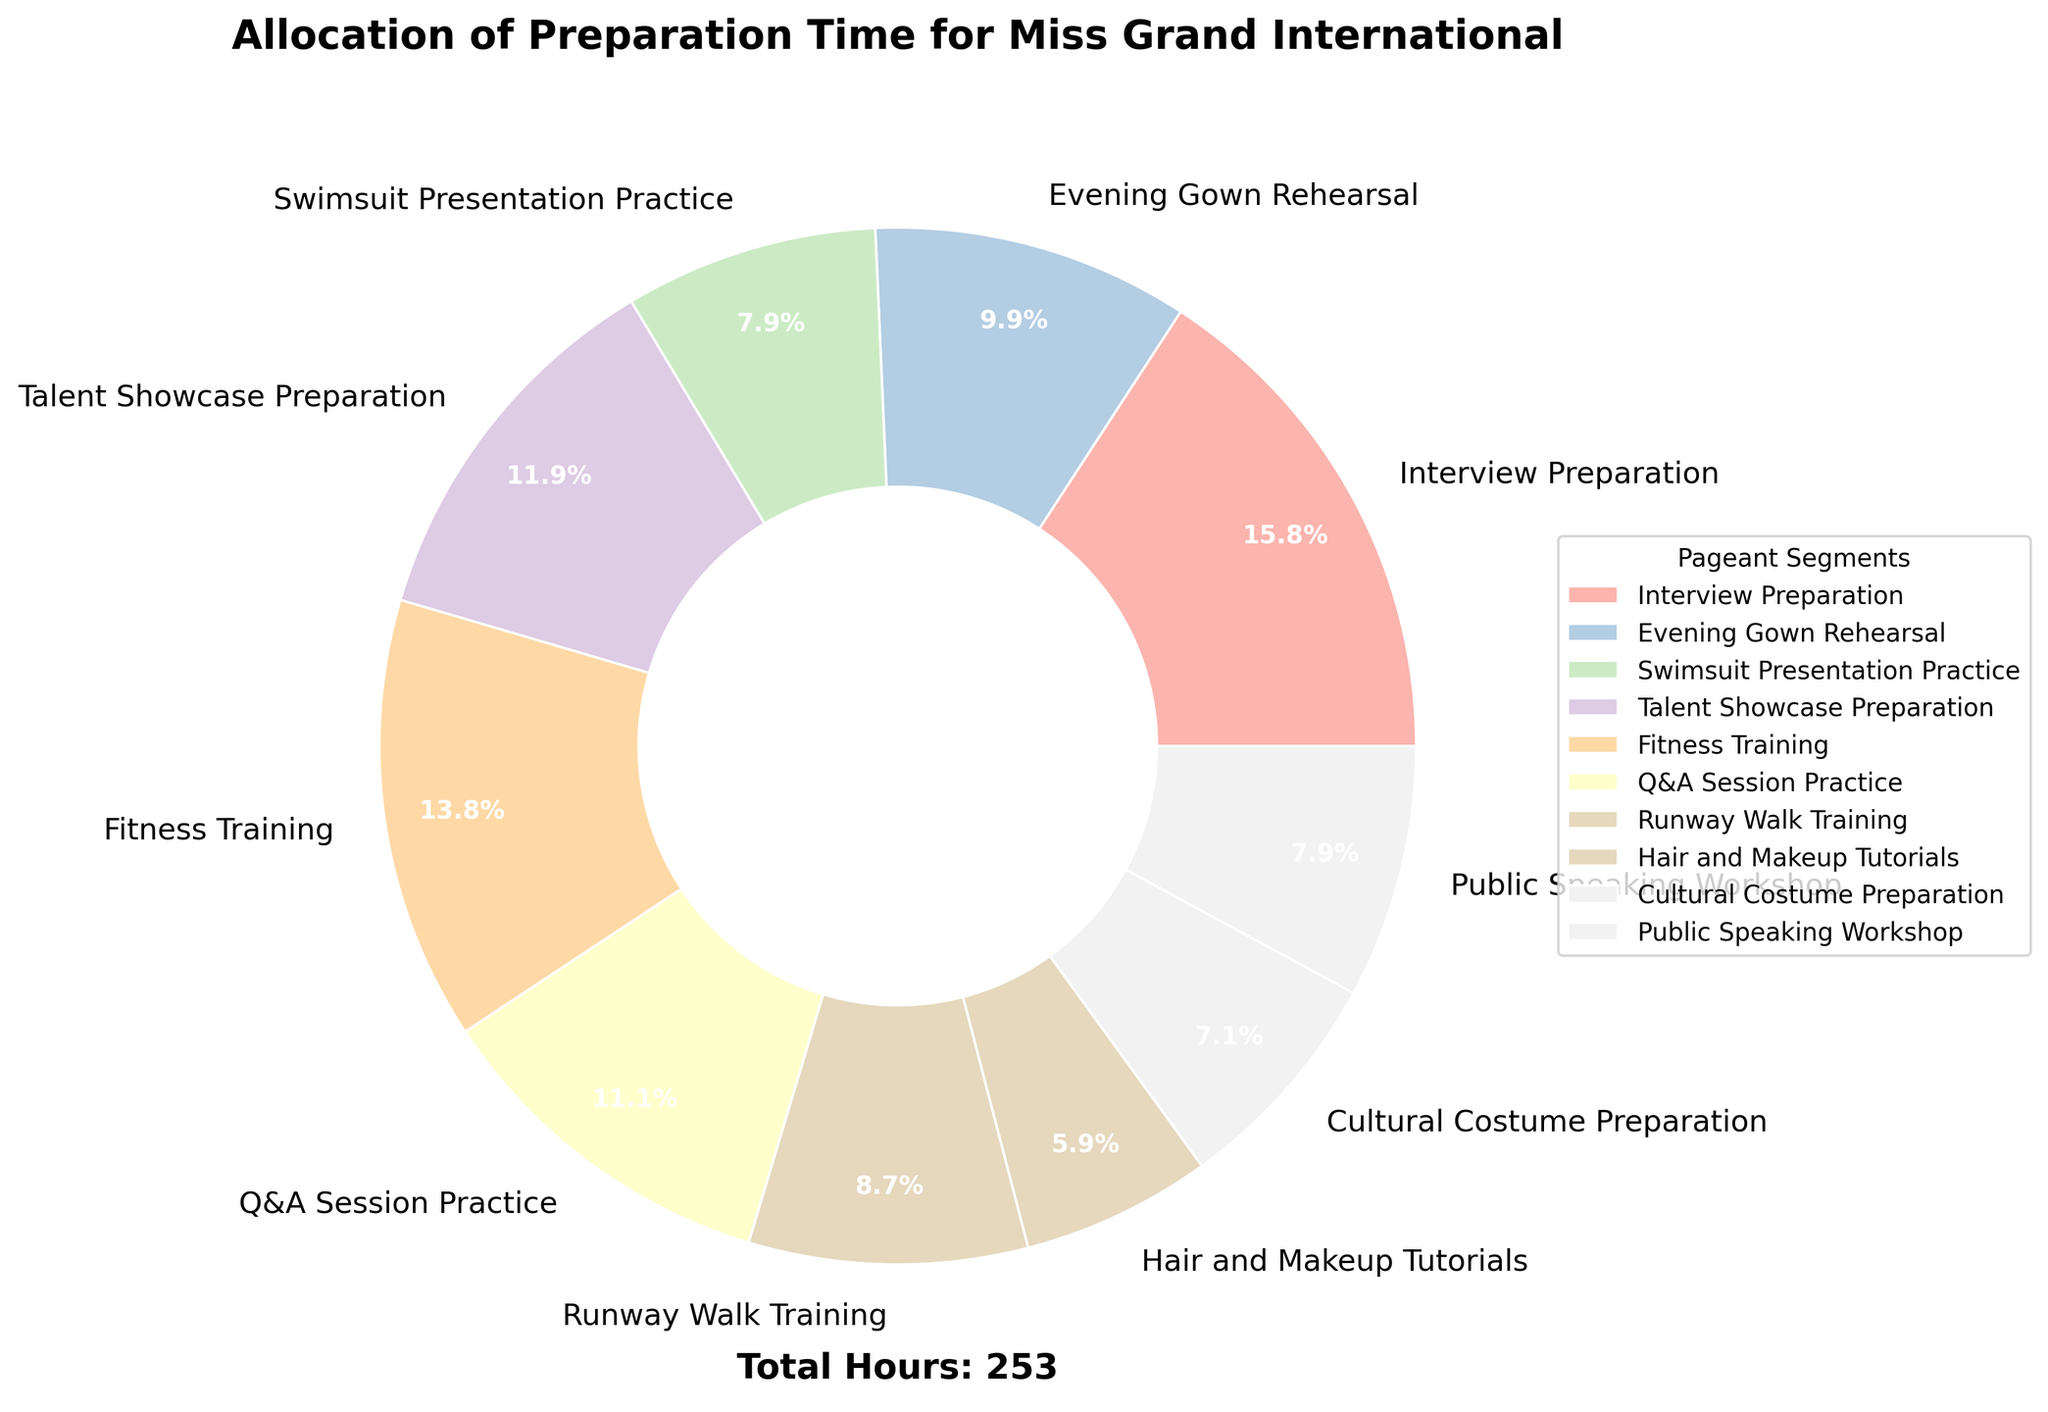What is the total number of hours allocated to Fitness Training and Talent Showcase Preparation combined? To determine this, simply add the hours allocated to Fitness Training and Talent Showcase Preparation. Fitness Training has 35 hours, and Talent Showcase Preparation has 30 hours. Therefore, the combined total is 35 + 30 = 65 hours.
Answer: 65 hours Which segment has the least amount of preparation time? To find the segment with the least preparation time, look for the smallest value on the pie chart. Hair and Makeup Tutorials have the least amount of time allocated, with 15 hours.
Answer: Hair and Makeup Tutorials How many more hours are allocated to Interview Preparation compared to Evening Gown Rehearsal? To find the number of additional hours allocated to Interview Preparation over Evening Gown Rehearsal, subtract the hours of Evening Gown Rehearsal from Interview Preparation. Interview Preparation has 40 hours, and Evening Gown Rehearsal has 25 hours. Thus, 40 - 25 = 15 hours more.
Answer: 15 hours more What is the average preparation time for Swimsuit Presentation Practice, Runway Walk Training, and Public Speaking Workshop? To calculate the average preparation time for these three segments, sum their hours and divide by the number of segments. Swimsuit Presentation Practice has 20 hours, Runway Walk Training has 22 hours, and Public Speaking Workshop has 20 hours. The total is 20 + 22 + 20 = 62 hours. The average is then 62 / 3 = 20.67 hours.
Answer: 20.67 hours Are there any segments with equal preparation time? If so, which ones? Look at the pie chart and see if any segments have the same number of hours allocated. Both Swimsuit Presentation Practice and Public Speaking Workshop have 20 hours each.
Answer: Swimsuit Presentation Practice and Public Speaking Workshop Which segment has a larger allocation, Cultural Costume Preparation or Q&A Session Practice? Compare the hours allocated to Cultural Costume Preparation and Q&A Session Practice. Cultural Costume Preparation has 18 hours, while Q&A Session Practice has 28 hours. Q&A Session Practice has a larger allocation.
Answer: Q&A Session Practice What fraction of the total preparation time is spent on Evening Gown Rehearsal? First, calculate the total number of preparation hours. Sum all the hours: 40 + 25 + 20 + 30 + 35 + 28 + 22 + 15 + 18 + 20 = 253 hours. Next, find the fraction of the total time that is spent on Evening Gown Rehearsal. Evening Gown Rehearsal is 25 hours, so the fraction is 25 / 253. This simplifies approximately to 0.0988.
Answer: Approximately 0.0988 Which segment has the second-highest allocation of preparation time? Identify the segment with the second-highest number of hours. The highest is Interview Preparation with 40 hours. The next highest is Fitness Training with 35 hours.
Answer: Fitness Training How much more time is allocated to Fitness Training compared to Hair and Makeup Tutorials? Subtract the hours allocated to Hair and Makeup Tutorials from those allocated to Fitness Training. Fitness Training has 35 hours, and Hair and Makeup Tutorials has 15 hours. Therefore, 35 - 15 = 20 hours.
Answer: 20 hours more 